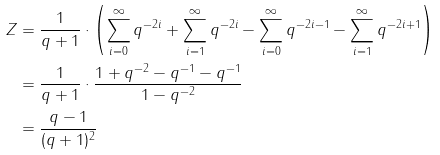Convert formula to latex. <formula><loc_0><loc_0><loc_500><loc_500>Z & = \frac { 1 } { q + 1 } \cdot \left ( \sum _ { i = 0 } ^ { \infty } q ^ { - 2 i } + \sum _ { i = 1 } ^ { \infty } q ^ { - 2 i } - \sum _ { i = 0 } ^ { \infty } q ^ { - 2 i - 1 } - \sum _ { i = 1 } ^ { \infty } q ^ { - 2 i + 1 } \right ) \\ & = \frac { 1 } { q + 1 } \cdot \frac { 1 + q ^ { - 2 } - q ^ { - 1 } - q ^ { - 1 } } { 1 - q ^ { - 2 } } \\ & = \frac { q - 1 } { ( q + 1 ) ^ { 2 } }</formula> 